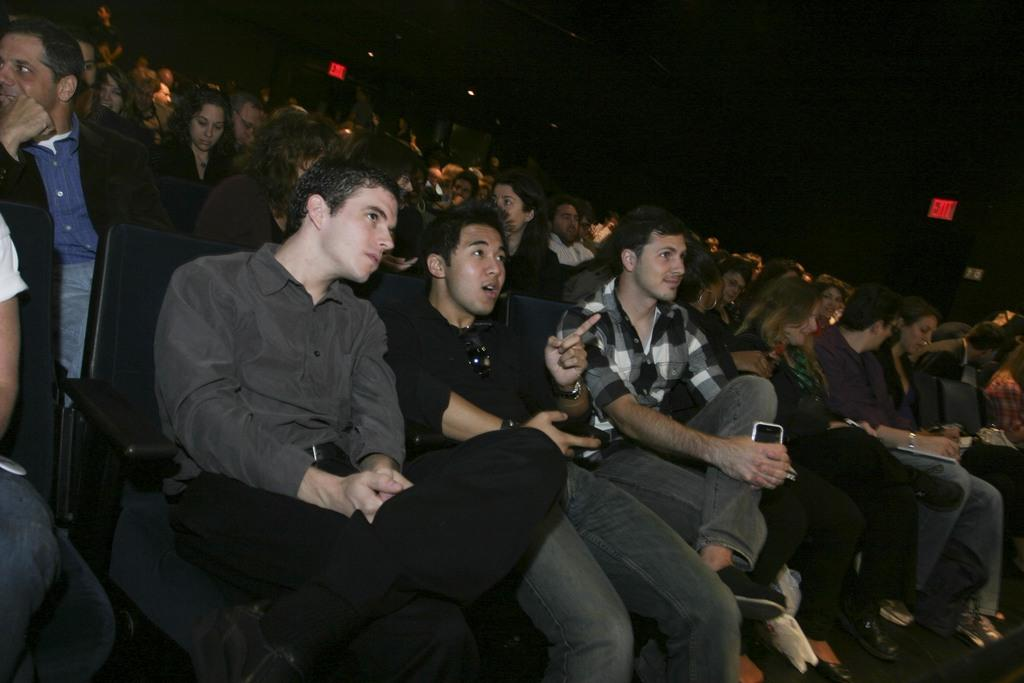What are the people in the image doing? The people in the image are sitting on chairs. Can you describe the person in the front? The person in the front is wearing goggles. What is another person holding in the image? Another person is holding a mobile. What can be said about the background of the image? The background of the image is dark. Can you tell me how many boats are docked at the harbor in the image? There is no harbor or boats present in the image; it features people sitting on chairs. What type of camera is being used by the person in the image? There is no camera visible in the image; the person in the front is wearing goggles. 